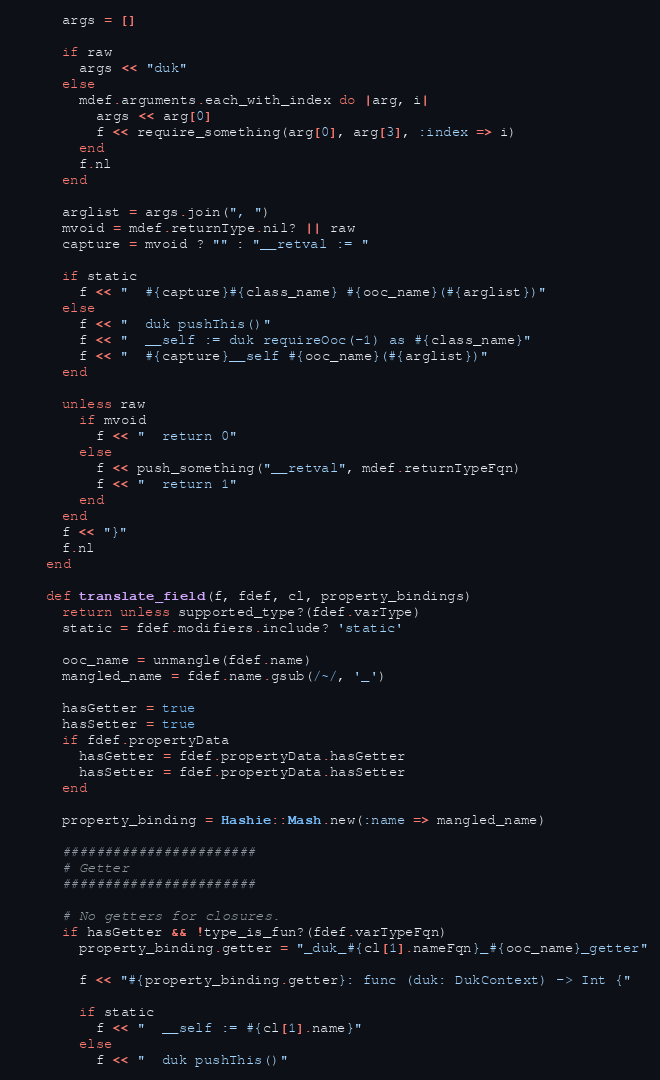Convert code to text. <code><loc_0><loc_0><loc_500><loc_500><_Ruby_>
      args = []

      if raw
        args << "duk"
      else
        mdef.arguments.each_with_index do |arg, i|
          args << arg[0]
          f << require_something(arg[0], arg[3], :index => i)
        end
        f.nl
      end

      arglist = args.join(", ")
      mvoid = mdef.returnType.nil? || raw
      capture = mvoid ? "" : "__retval := "

      if static
        f << "  #{capture}#{class_name} #{ooc_name}(#{arglist})"
      else
        f << "  duk pushThis()"
        f << "  __self := duk requireOoc(-1) as #{class_name}"
        f << "  #{capture}__self #{ooc_name}(#{arglist})"
      end

      unless raw
        if mvoid
          f << "  return 0"
        else
          f << push_something("__retval", mdef.returnTypeFqn)
          f << "  return 1"
        end
      end
      f << "}"
      f.nl
    end

    def translate_field(f, fdef, cl, property_bindings)
      return unless supported_type?(fdef.varType)
      static = fdef.modifiers.include? 'static'

      ooc_name = unmangle(fdef.name)
      mangled_name = fdef.name.gsub(/~/, '_')

      hasGetter = true
      hasSetter = true
      if fdef.propertyData
        hasGetter = fdef.propertyData.hasGetter
        hasSetter = fdef.propertyData.hasSetter
      end

      property_binding = Hashie::Mash.new(:name => mangled_name)

      #######################
      # Getter
      #######################
      
      # No getters for closures.
      if hasGetter && !type_is_fun?(fdef.varTypeFqn)
        property_binding.getter = "_duk_#{cl[1].nameFqn}_#{ooc_name}_getter"

        f << "#{property_binding.getter}: func (duk: DukContext) -> Int {"

        if static
          f << "  __self := #{cl[1].name}"
        else
          f << "  duk pushThis()"</code> 